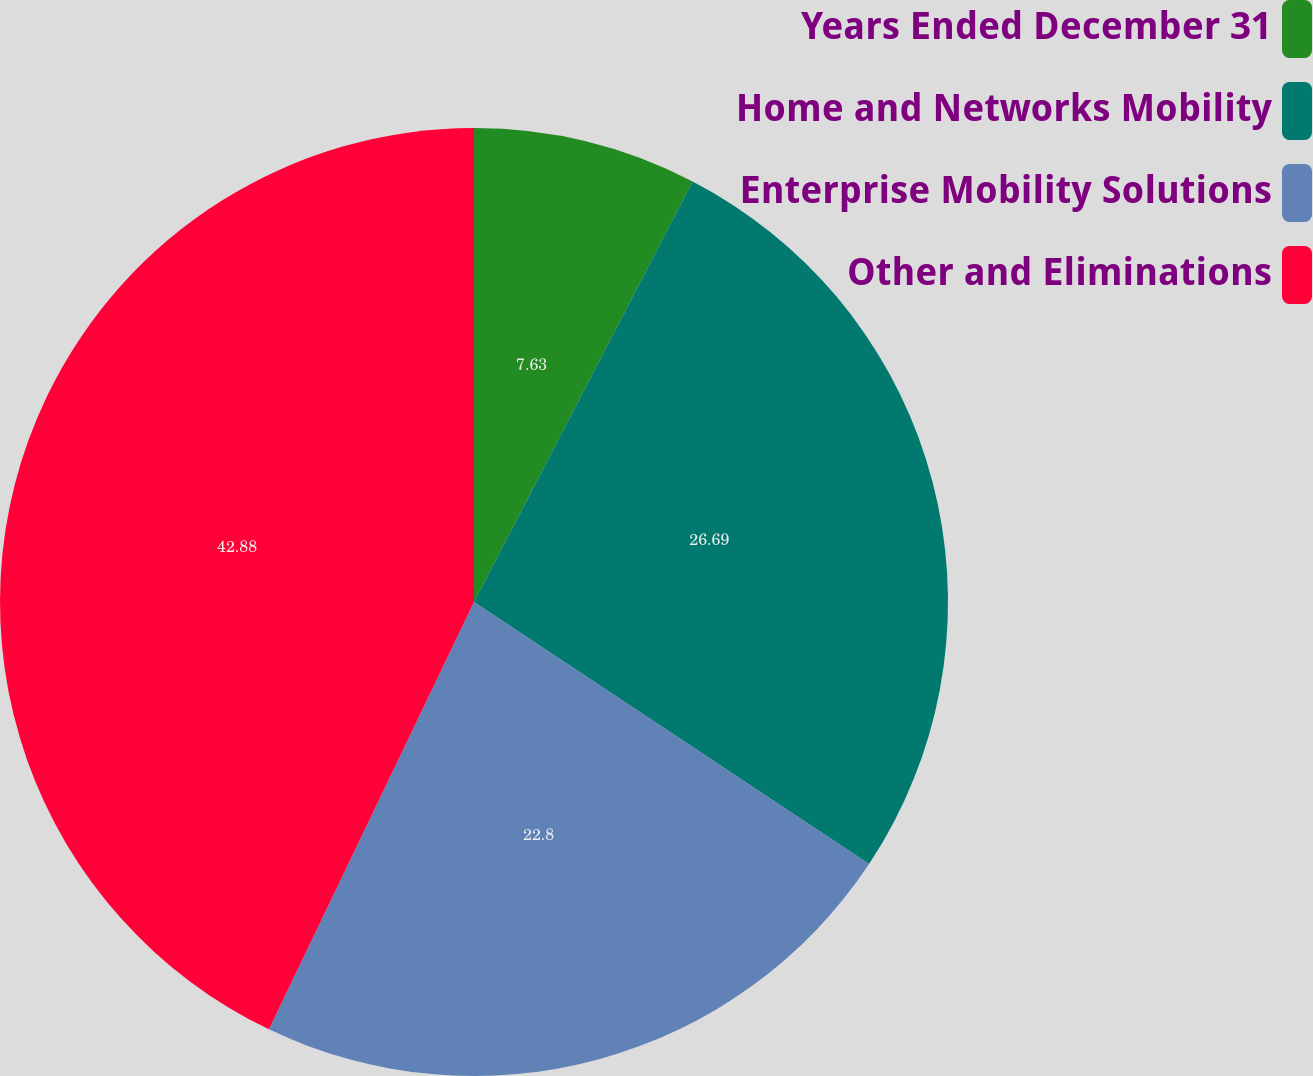Convert chart. <chart><loc_0><loc_0><loc_500><loc_500><pie_chart><fcel>Years Ended December 31<fcel>Home and Networks Mobility<fcel>Enterprise Mobility Solutions<fcel>Other and Eliminations<nl><fcel>7.63%<fcel>26.69%<fcel>22.8%<fcel>42.88%<nl></chart> 